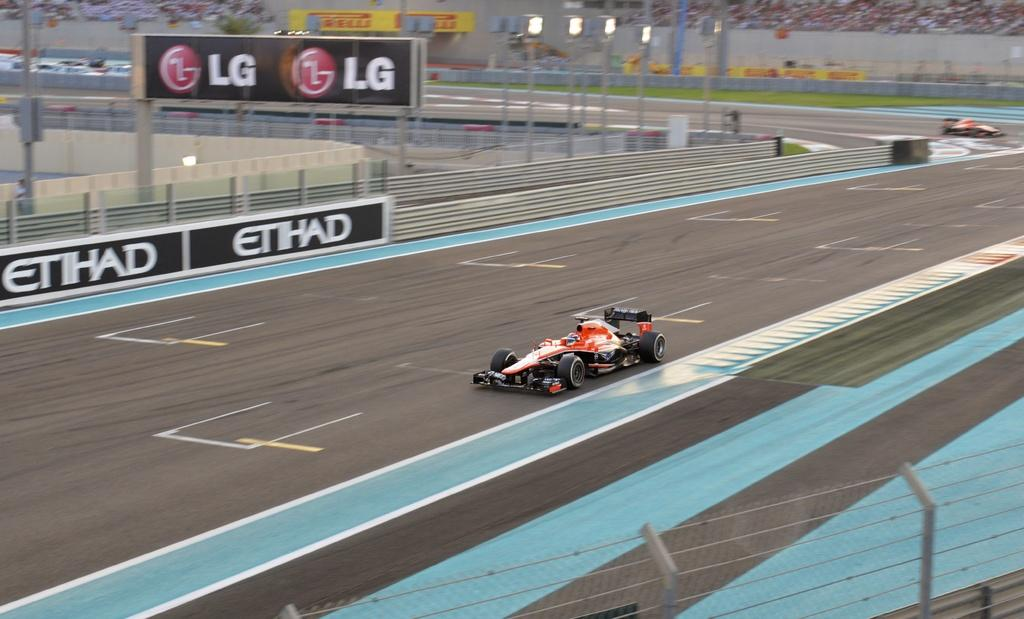What objects are present in the image that are used for carrying items? There are carts in the image that are used for carrying items. What type of barrier can be seen in the image? There is a fence in the image. What is hanging in the image that might be used for advertising or conveying information? There is a banner in the image. What type of illumination is present in the image? There are lights in the image. What can be seen in the background of the image that suggests the presence of people? There is a group of people in the background of the image. Can you tell me how deep the lake is in the image? There is no lake present in the image. What type of control system is used to manage the movement of the carts in the image? There is no control system mentioned or visible in the image; the carts are likely being pushed or pulled by people. 